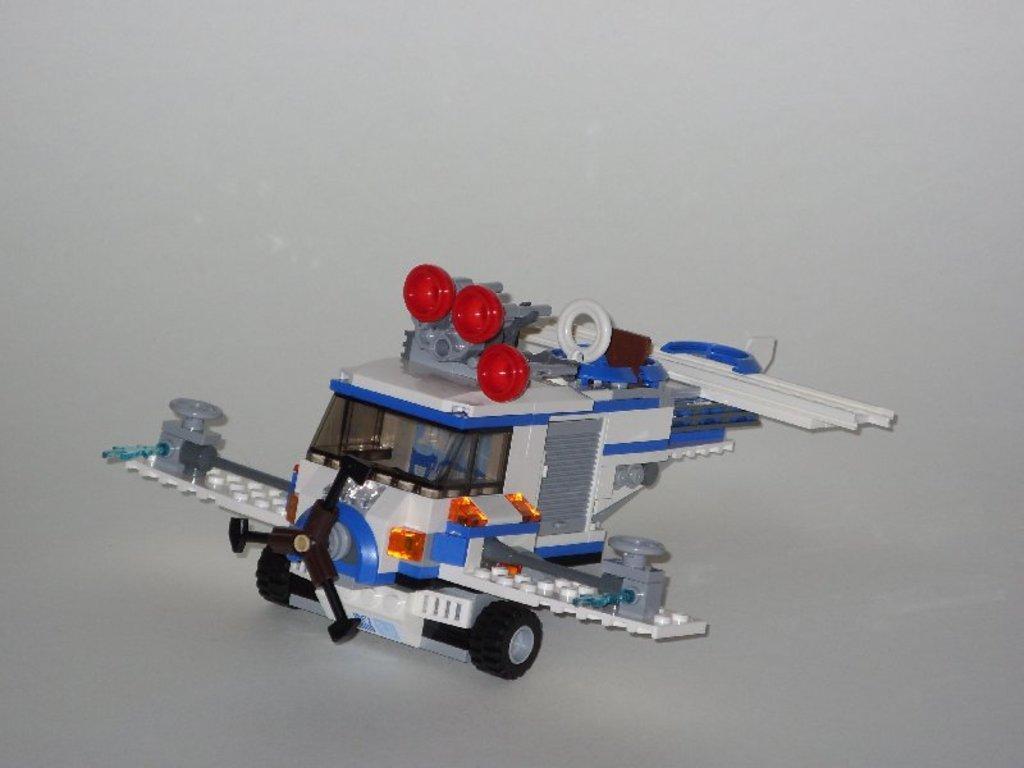Please provide a concise description of this image. In this image, in the middle, we can see a toy vehicle. In the background, we can see white color. 